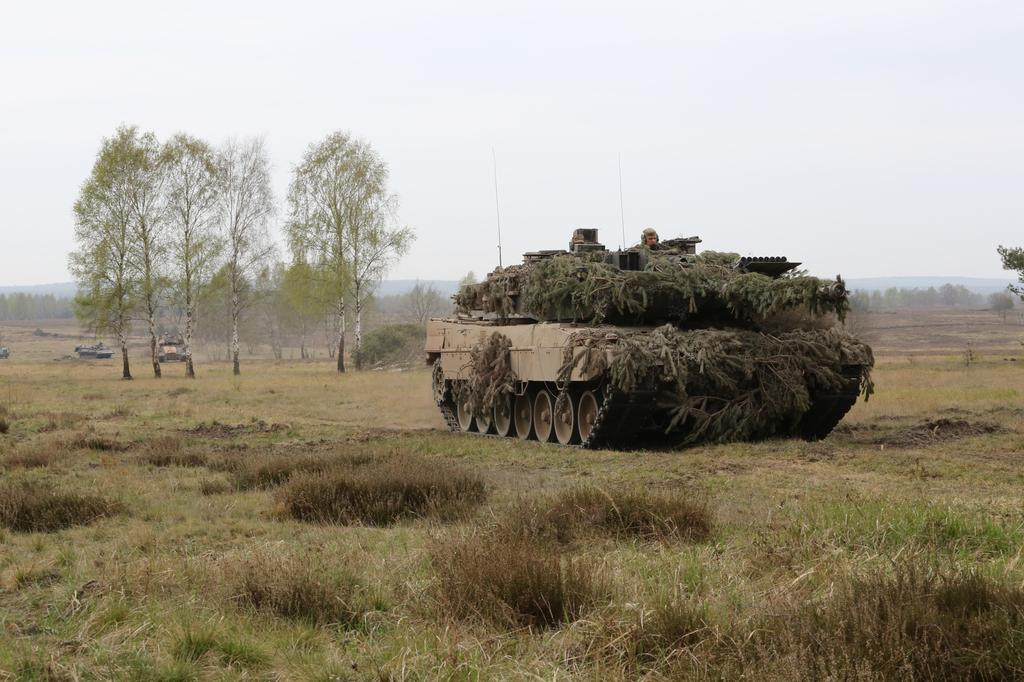What is the person in the image sitting in? There is a person sitting in an armored car in the image. What type of terrain is visible in the image? There is grass, trees, and hills visible in the image. What is the condition of the sky in the image? The sky is visible and appears cloudy in the image. Where is the pocket located on the armored car? There is no pocket present on the armored car in the image. What type of bucket can be seen in the image? There is no bucket present in the image. 